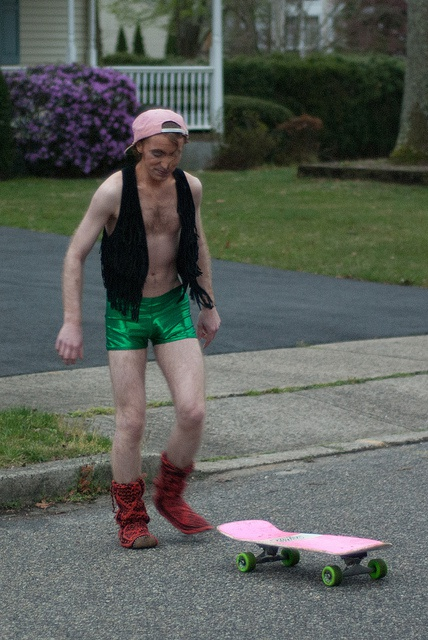Describe the objects in this image and their specific colors. I can see people in black, gray, and darkgray tones and skateboard in black, pink, and gray tones in this image. 